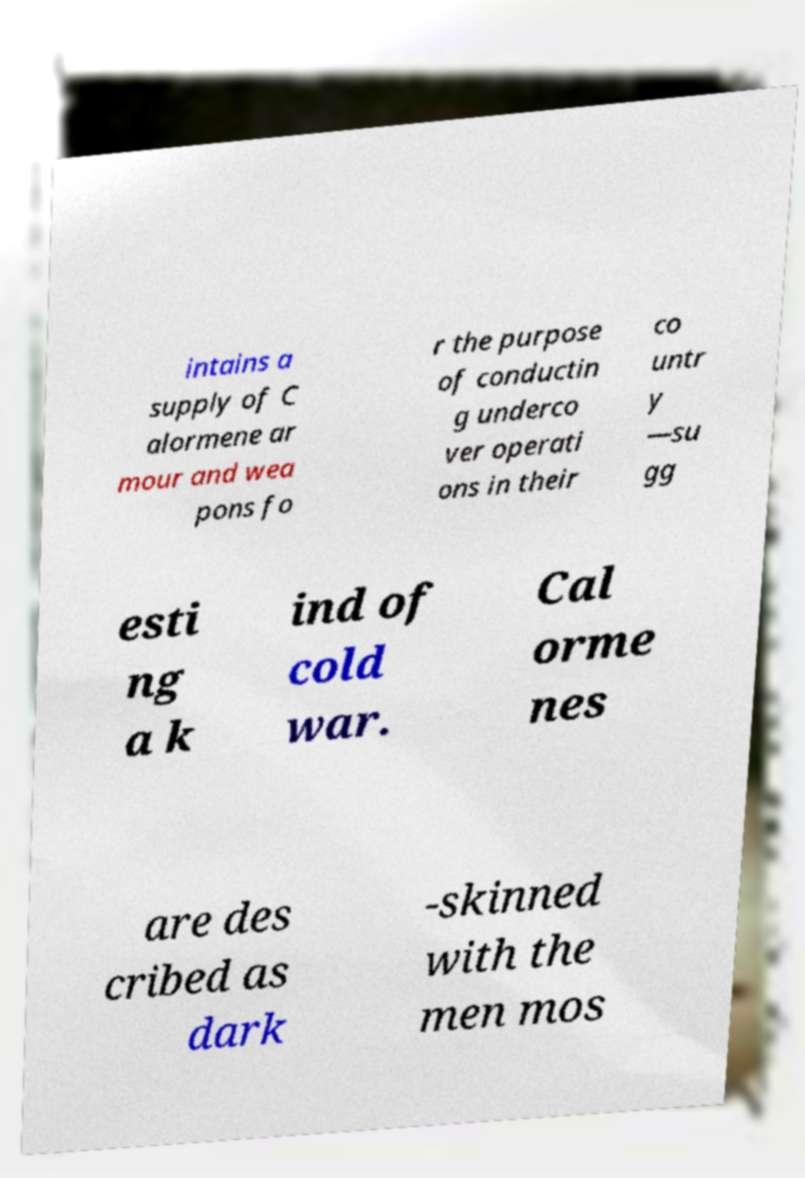Please identify and transcribe the text found in this image. intains a supply of C alormene ar mour and wea pons fo r the purpose of conductin g underco ver operati ons in their co untr y —su gg esti ng a k ind of cold war. Cal orme nes are des cribed as dark -skinned with the men mos 